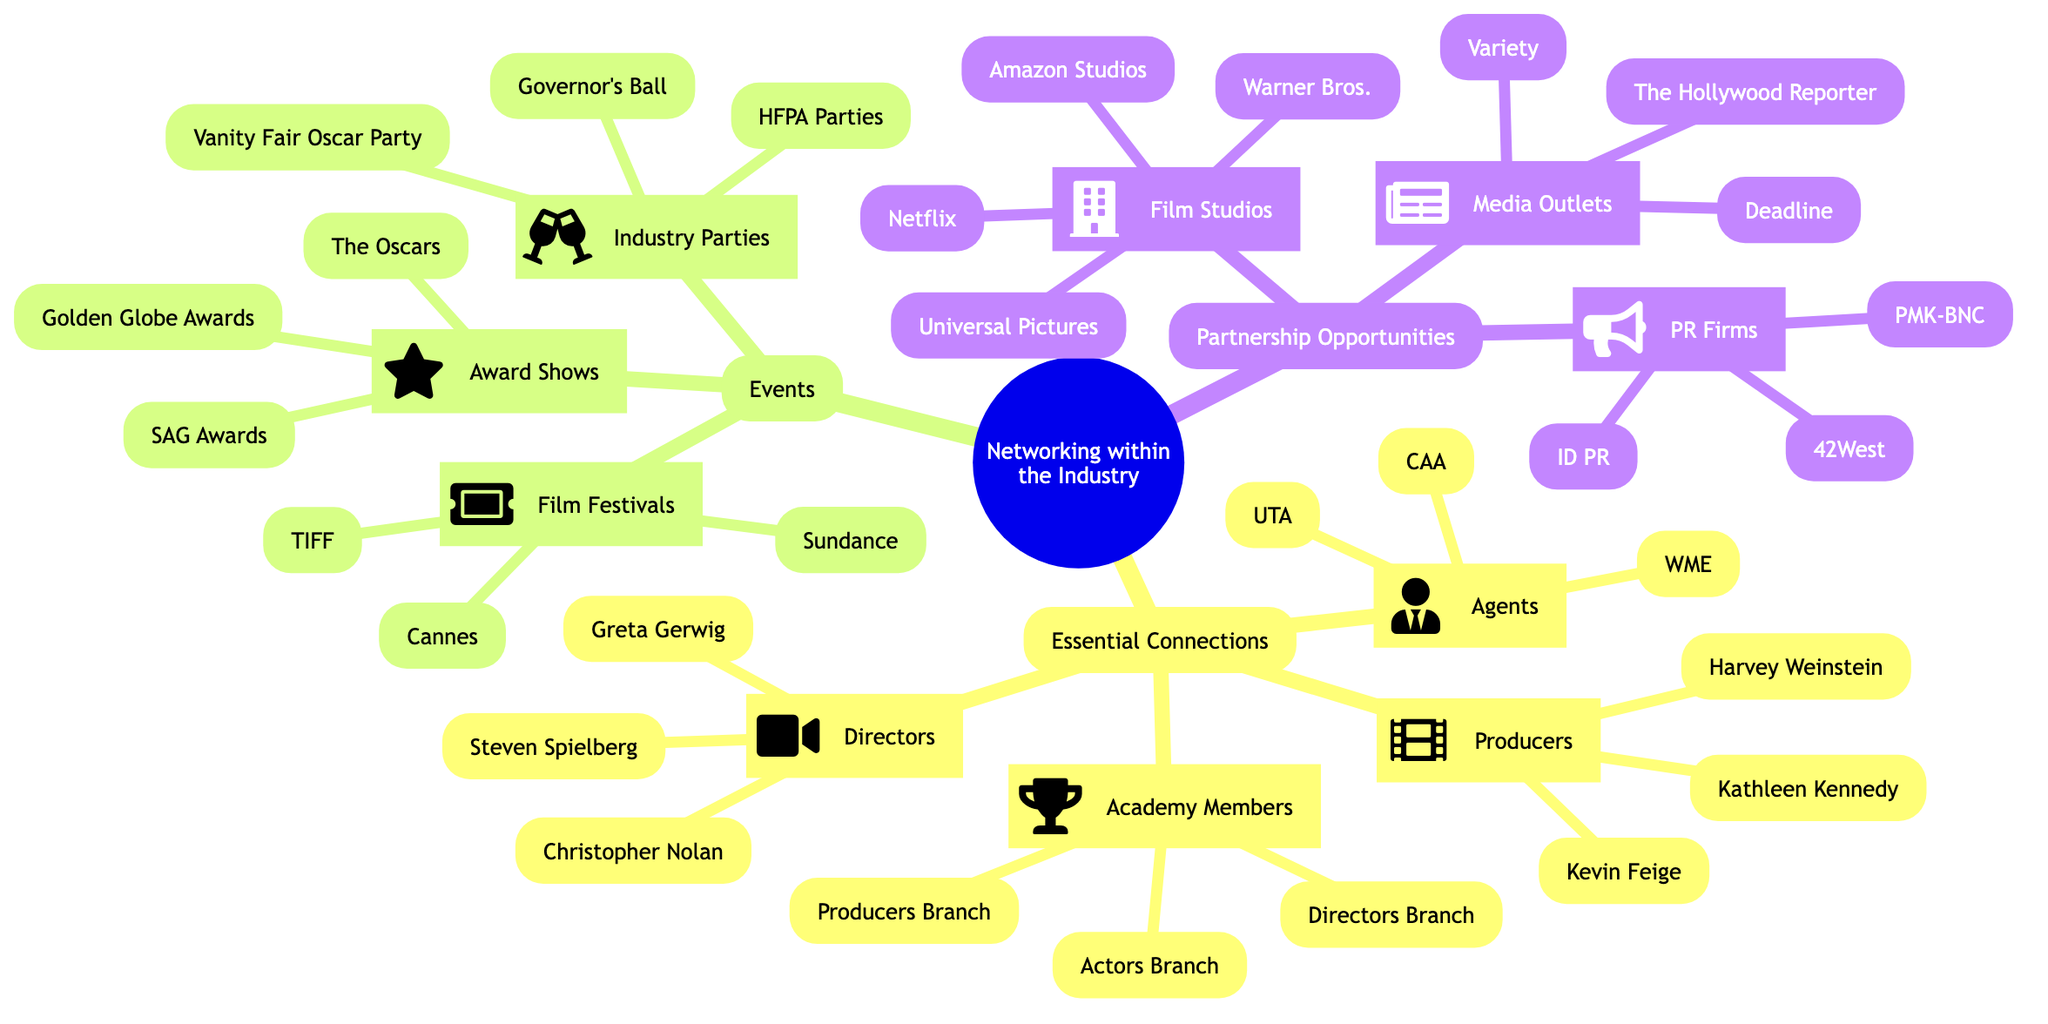What are the names of at least two major public relations firms mentioned? The diagram lists three public relations firms under the "Partnership Opportunities" section: 42West, ID PR, and PMK-BNC. Based on the prompt, we only need to provide two of them.
Answer: 42West, ID PR How many award shows are listed in the events section? In the "Events" section, there is one category labeled "Award Shows," with three items listed: The Oscars, Golden Globe Awards, and SAG Awards. Therefore, there are three award shows in total.
Answer: 3 Who is one of the directors listed in the essential connections? Looking at the "Essential Connections" section under "Directors," we see three names: Steven Spielberg, Christopher Nolan, and Greta Gerwig. We can choose any one of these names as a valid answer.
Answer: Steven Spielberg What type of organizations are included under Partnership Opportunities? There are three categories listed under "Partnership Opportunities": Film Studios, Public Relations Firms, and Media Outlets. Therefore, the types of organizations include studios, PR firms, and media outlets.
Answer: Film Studios, PR Firms, Media Outlets How many film festivals are listed in the events section? In the "Film Festivals" category under the "Events" section, three specific film festivals are named: Cannes Film Festival, Sundance Film Festival, and Toronto International Film Festival. Thus, the count is three.
Answer: 3 What connection does "Harvey Weinstein" represent in the diagram? Harvey Weinstein is listed under the "Producers" category within the "Essential Connections" section of the diagram. Therefore, he represents a producer connection.
Answer: Producer Which media outlet is mentioned in the partnership opportunities? The diagram lists three media outlets under the "Media Outlets" category in the "Partnership Opportunities" section: Variety, The Hollywood Reporter, and Deadline. Any of these can be a valid answer.
Answer: Variety Name one award show mentioned in the events section. Under the "Events" section, in the "Award Shows" category, several awards are listed, including The Oscars, Golden Globe Awards, and SAG Awards. Picking any one of these would be appropriate.
Answer: The Oscars 